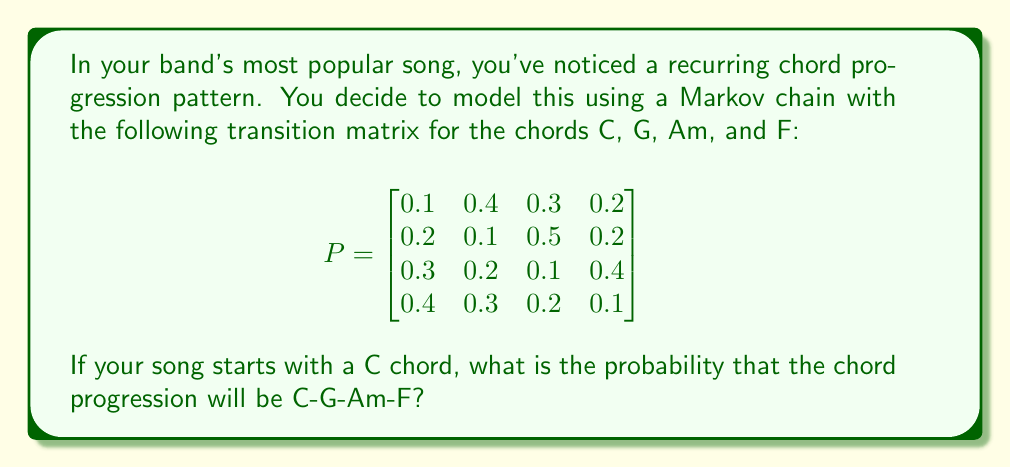Show me your answer to this math problem. Let's approach this step-by-step:

1) In a Markov chain, the probability of a specific sequence of states is the product of the transition probabilities between those states.

2) We need to find:
   P(C → G) × P(G → Am) × P(Am → F)

3) From the transition matrix:
   - P(C → G) is in the 1st row, 2nd column: 0.4
   - P(G → Am) is in the 2nd row, 3rd column: 0.5
   - P(Am → F) is in the 3rd row, 4th column: 0.4

4) Now, let's multiply these probabilities:

   $$P(\text{C-G-Am-F}) = 0.4 \times 0.5 \times 0.4 = 0.08$$

5) To convert to a percentage, we multiply by 100:

   $$0.08 \times 100 = 8\%$$

Therefore, the probability of the chord progression C-G-Am-F occurring, given that the song starts with a C chord, is 8%.
Answer: 8% or 0.08 